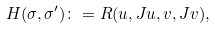Convert formula to latex. <formula><loc_0><loc_0><loc_500><loc_500>H ( \sigma , \sigma ^ { \prime } ) \colon = R ( u , J u , v , J v ) ,</formula> 